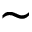Convert formula to latex. <formula><loc_0><loc_0><loc_500><loc_500>\sim</formula> 